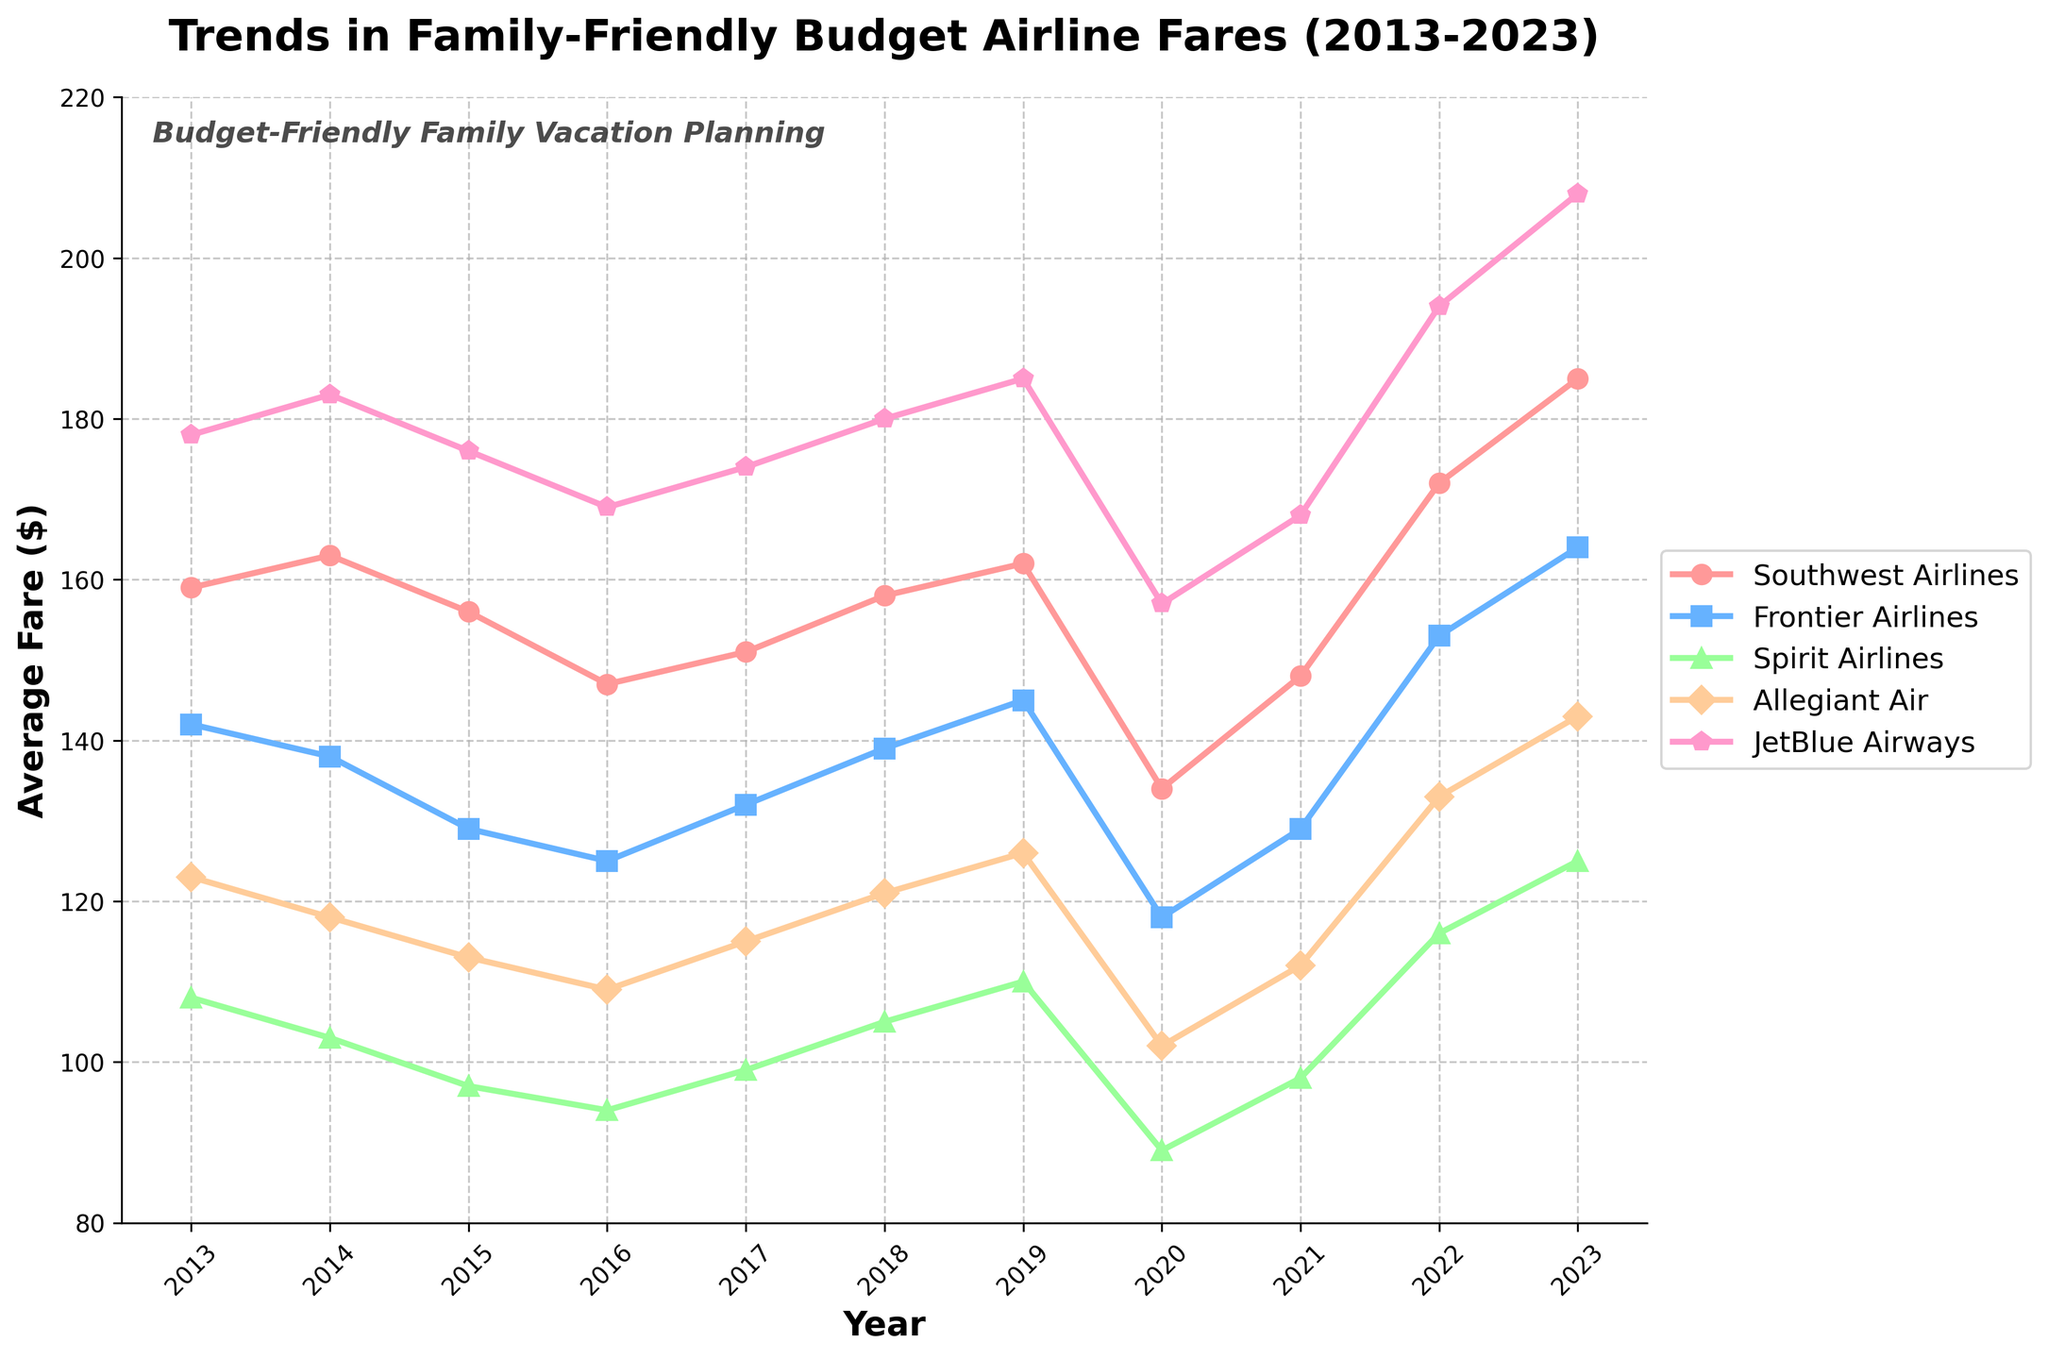Which airline had the highest average fare in 2013? To determine the highest average fare in 2013, we look for the largest value in the year 2013 column for each airline. JetBlue Airways has the highest fare at $178.
Answer: JetBlue Airways In which year did Southwest Airlines experience its lowest average fare? By observing the trend line for Southwest Airlines, we find that the lowest point occurs in 2020 with a fare of $134.
Answer: 2020 Did any airline show a continuous increase in average fare every year from 2019 to 2023? We check if any airline's data shows a consistent upward trend year over year between 2019 and 2023. Only Spirit Airlines shows a continuous increase from $110 in 2019 to $125 in 2023.
Answer: Spirit Airlines What is the average fare for Spirit Airlines over the last decade? Summing Spirit Airlines fares from 2013 to 2023: 108 + 103 + 97 + 94 + 99 + 105 + 110 + 89 + 98 + 116 + 125 = 1144. Then, dividing by the number of years (11), the average fare is 1144 / 11 = 104.
Answer: 104 How much has the average fare for JetBlue Airways increased from 2013 to 2023? Subtracting the fare in 2013 ($178) from the fare in 2023 ($208): 208 - 178 = 30.
Answer: 30 Which two airlines had the closest average fares in 2017? Looking at 2017, the fares are: Southwest Airlines $151, Frontier Airlines $132, Spirit Airlines $99, Allegiant Air $115, and JetBlue Airways $174. The closest fares are for Allegiant Air and Frontier Airlines, with a difference of 115 - 132 = 17.
Answer: Allegiant Air and Frontier Airlines Which airline had the highest fare decrease between any two consecutive years? Comparing the fare difference between consecutive years for each airline, the highest decrease is from Southwest Airlines between 2019 to 2020: 162 - 134 = 28.
Answer: Southwest Airlines In 2023, which airline had the lowest average fare? Looking at the 2023 fares: Southwest Airlines $185, Frontier Airlines $164, Spirit Airlines $125, Allegiant Air $143, and JetBlue Airways $208. Spirit Airlines has the lowest fare at $125.
Answer: Spirit Airlines What is the difference between the highest average fare and the lowest average fare in 2018? In 2018, the highest fare is JetBlue Airways at $180 and the lowest is Spirit Airlines at $105. The difference is 180 - 105 = 75.
Answer: 75 Comparing 2015 and 2023, which airline showed the most significant rise in average fare and by how much? Calculating the difference from 2015 to 2023 for each airline: Southwest Airlines (185 - 156 = 29), Frontier Airlines (164 - 129 = 35), Spirit Airlines (125 - 97 = 28), Allegiant Air (143 - 113 = 30), and JetBlue Airways (208 - 176 = 32). Frontier Airlines showed the most significant rise, increasing by 35.
Answer: Frontier Airlines, 35 